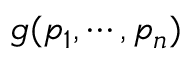Convert formula to latex. <formula><loc_0><loc_0><loc_500><loc_500>g ( p _ { 1 } , \cdots , p _ { n } )</formula> 